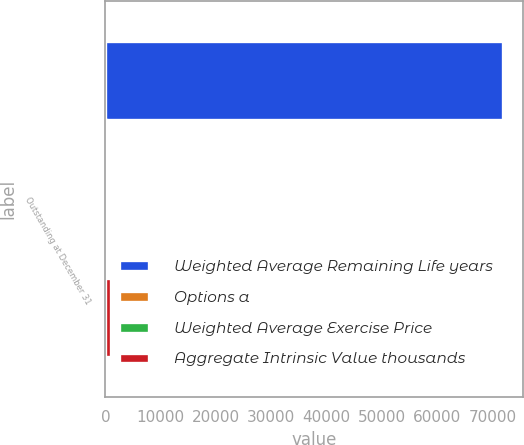<chart> <loc_0><loc_0><loc_500><loc_500><stacked_bar_chart><ecel><fcel>Outstanding at December 31<nl><fcel>Weighted Average Remaining Life years<fcel>71892<nl><fcel>Options a<fcel>39.03<nl><fcel>Weighted Average Exercise Price<fcel>0.18<nl><fcel>Aggregate Intrinsic Value thousands<fcel>1046<nl></chart> 